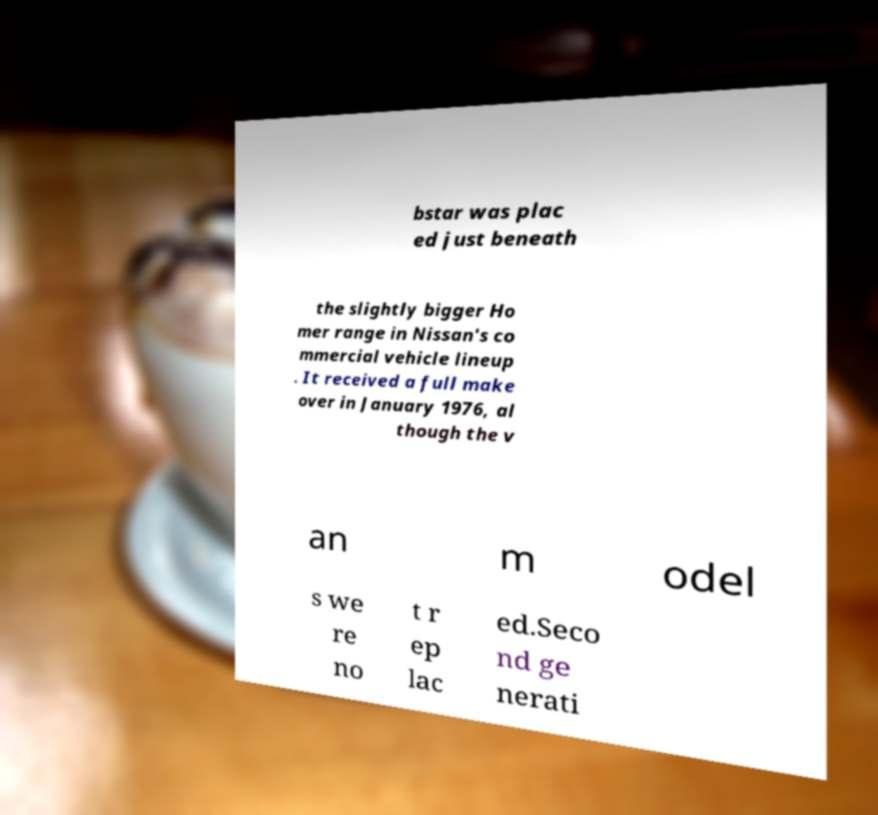For documentation purposes, I need the text within this image transcribed. Could you provide that? bstar was plac ed just beneath the slightly bigger Ho mer range in Nissan's co mmercial vehicle lineup . It received a full make over in January 1976, al though the v an m odel s we re no t r ep lac ed.Seco nd ge nerati 